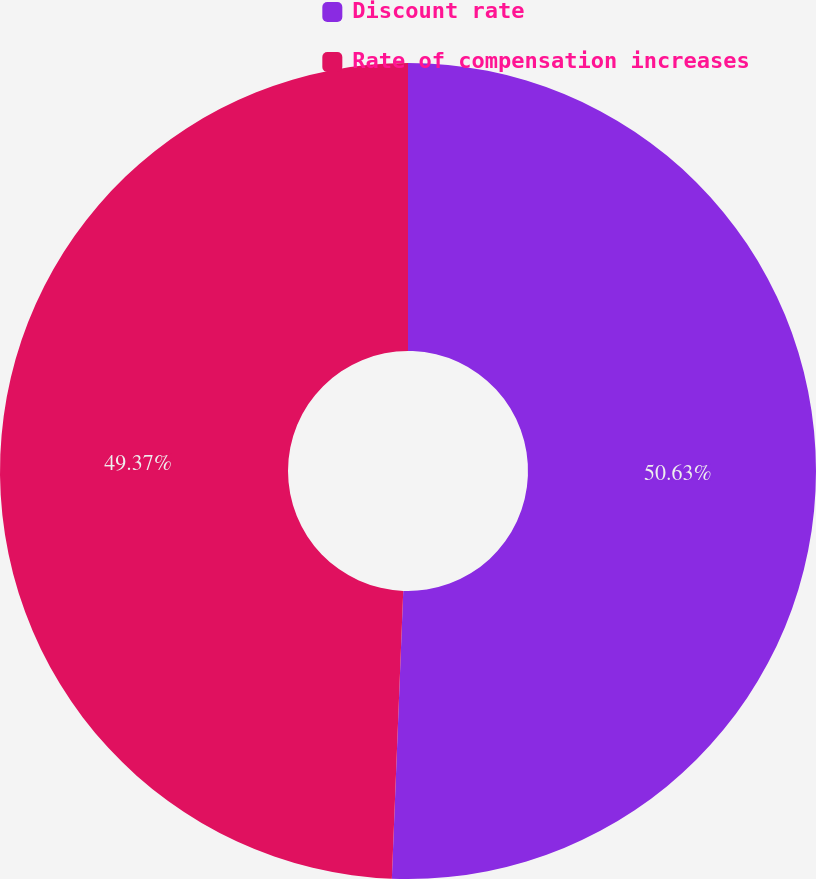Convert chart to OTSL. <chart><loc_0><loc_0><loc_500><loc_500><pie_chart><fcel>Discount rate<fcel>Rate of compensation increases<nl><fcel>50.63%<fcel>49.37%<nl></chart> 